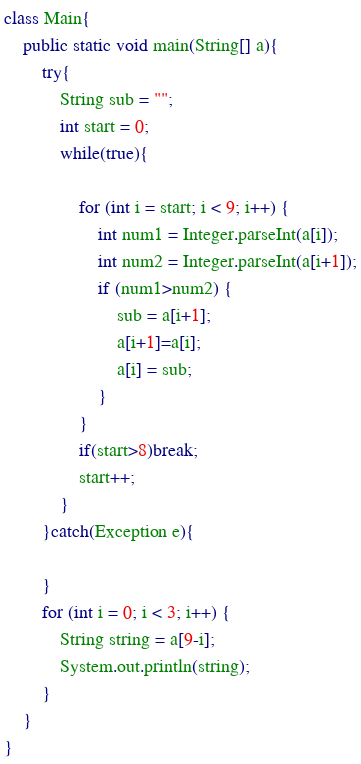<code> <loc_0><loc_0><loc_500><loc_500><_Java_>class Main{
    public static void main(String[] a){
		try{
			String sub = "";
			int start = 0;
			while(true){

				for (int i = start; i < 9; i++) {
					int num1 = Integer.parseInt(a[i]);
					int num2 = Integer.parseInt(a[i+1]);
					if (num1>num2) {
						sub = a[i+1];
						a[i+1]=a[i];
						a[i] = sub;
					}
				}
				if(start>8)break;
				start++;
			}
		}catch(Exception e){
			
		}
		for (int i = 0; i < 3; i++) {
			String string = a[9-i];
			System.out.println(string);
		}
    }
}</code> 